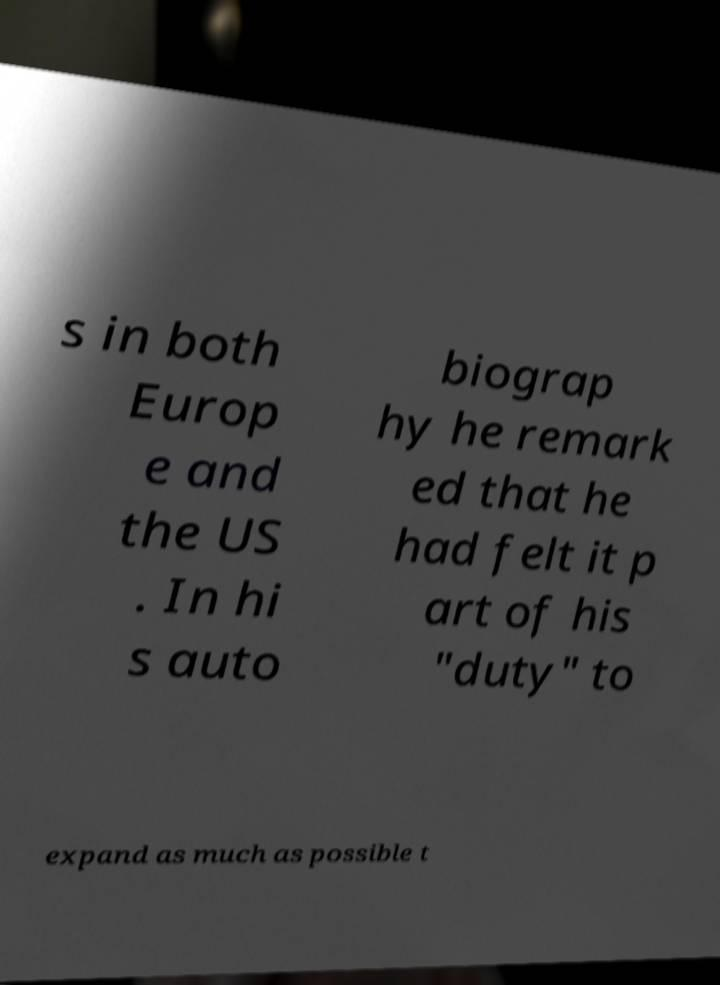Can you read and provide the text displayed in the image?This photo seems to have some interesting text. Can you extract and type it out for me? s in both Europ e and the US . In hi s auto biograp hy he remark ed that he had felt it p art of his "duty" to expand as much as possible t 